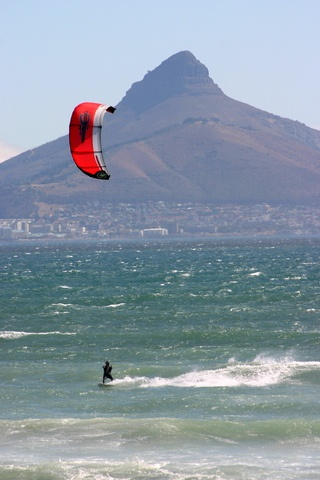Describe the objects in this image and their specific colors. I can see kite in lavender, red, maroon, and black tones, people in lavender, black, and gray tones, and surfboard in lavender, gray, darkgray, and lightgray tones in this image. 